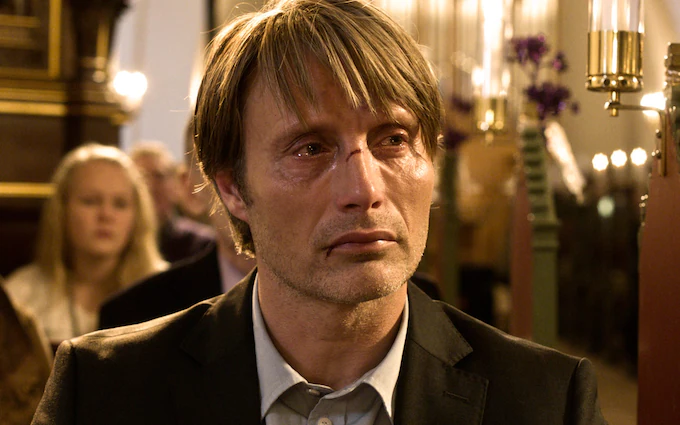Describe the ambiance and setting of the image in detail. The ambiance of the image is solemn and reflective, set within the confines of a grand church. The man stands in the foreground, dressed in a formal black suit, giving an air of sophistication and somberness. The background, though blurred, reveals a large pipe organ and the silhouettes of other individuals, indicating that this is a place where important ceremonies or gatherings occur. The lighting is warm and subdued, casting soft glows that enhance the solemnity of the scene. The church’s architectural elements, such as ornate decorations and tall columns, suggest a place of reverence and historical significance. What might be the significance of the church setting in the image? The church setting in the image adds layers of meaning and depth to the man's emotional state. Churches are often associated with ceremonies such as weddings, funerals, and confessions, suggesting that the man might be at a pivotal moment in his life. The solemn environment of the church, along with the grandeur and historical weight of its architecture, amplifies the gravity of the man's emotions, perhaps indicating a personal loss or search for solace. 